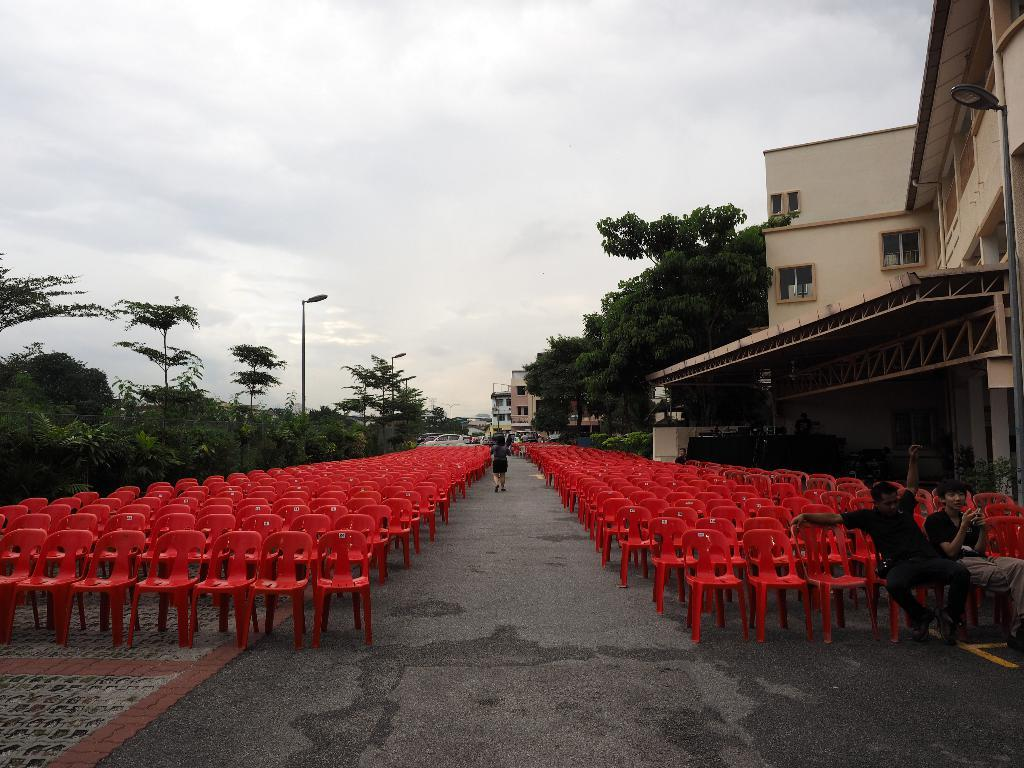How are the chairs arranged in the image? The chairs are arranged in the image. Who or what is present in the image along with the chairs? There are people present in the image. What can be seen in the background of the image? Buildings and trees are visible in the image. What type of disease is being treated by the representative in the image? There is no representative or disease present in the image. How many chickens can be seen in the image? There are no chickens present in the image. 